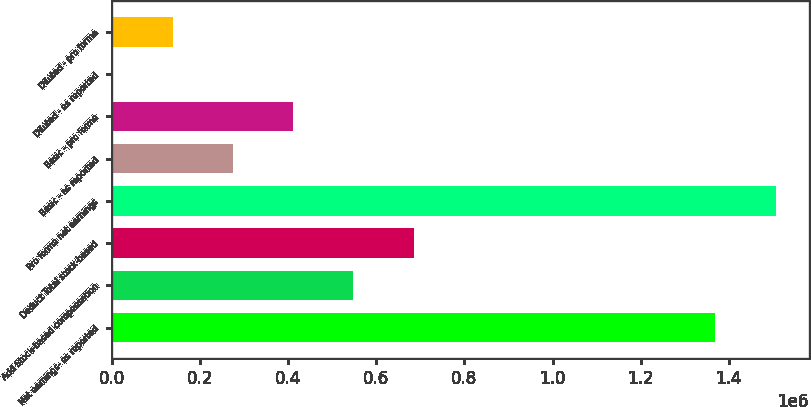Convert chart. <chart><loc_0><loc_0><loc_500><loc_500><bar_chart><fcel>Net earnings- as reported<fcel>Add Stock-based compensation<fcel>Deduct Total stock-based<fcel>Pro forma net earnings<fcel>Basic - as reported<fcel>Basic - pro forma<fcel>Diluted - as reported<fcel>Diluted - pro forma<nl><fcel>1.3699e+06<fcel>547964<fcel>684954<fcel>1.50689e+06<fcel>273984<fcel>410974<fcel>4.19<fcel>136994<nl></chart> 